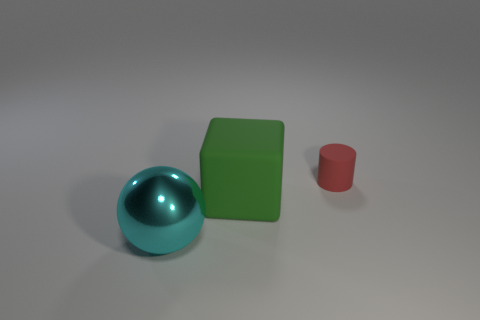Are there any other objects that have the same material as the tiny object?
Your answer should be very brief. Yes. Are there any other things that are the same material as the large block?
Your answer should be very brief. Yes. The red cylinder behind the matte thing that is in front of the small red rubber object is made of what material?
Your answer should be very brief. Rubber. There is a matte thing that is left of the tiny red rubber cylinder that is on the right side of the big object that is on the right side of the metal object; how big is it?
Ensure brevity in your answer.  Large. What number of other things are the same shape as the cyan metallic object?
Provide a short and direct response. 0. There is a thing that is the same size as the rubber cube; what is its color?
Keep it short and to the point. Cyan. Are there any tiny matte cylinders of the same color as the big cube?
Your answer should be very brief. No. There is a object that is left of the rubber cube; is it the same size as the large cube?
Keep it short and to the point. Yes. Are there an equal number of large green things on the left side of the small thing and metal things?
Provide a succinct answer. Yes. How many objects are either objects that are right of the matte cube or big cyan things?
Keep it short and to the point. 2. 